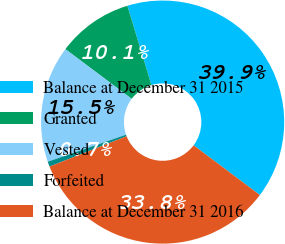Convert chart to OTSL. <chart><loc_0><loc_0><loc_500><loc_500><pie_chart><fcel>Balance at December 31 2015<fcel>Granted<fcel>Vested<fcel>Forfeited<fcel>Balance at December 31 2016<nl><fcel>39.93%<fcel>10.07%<fcel>15.53%<fcel>0.68%<fcel>33.79%<nl></chart> 